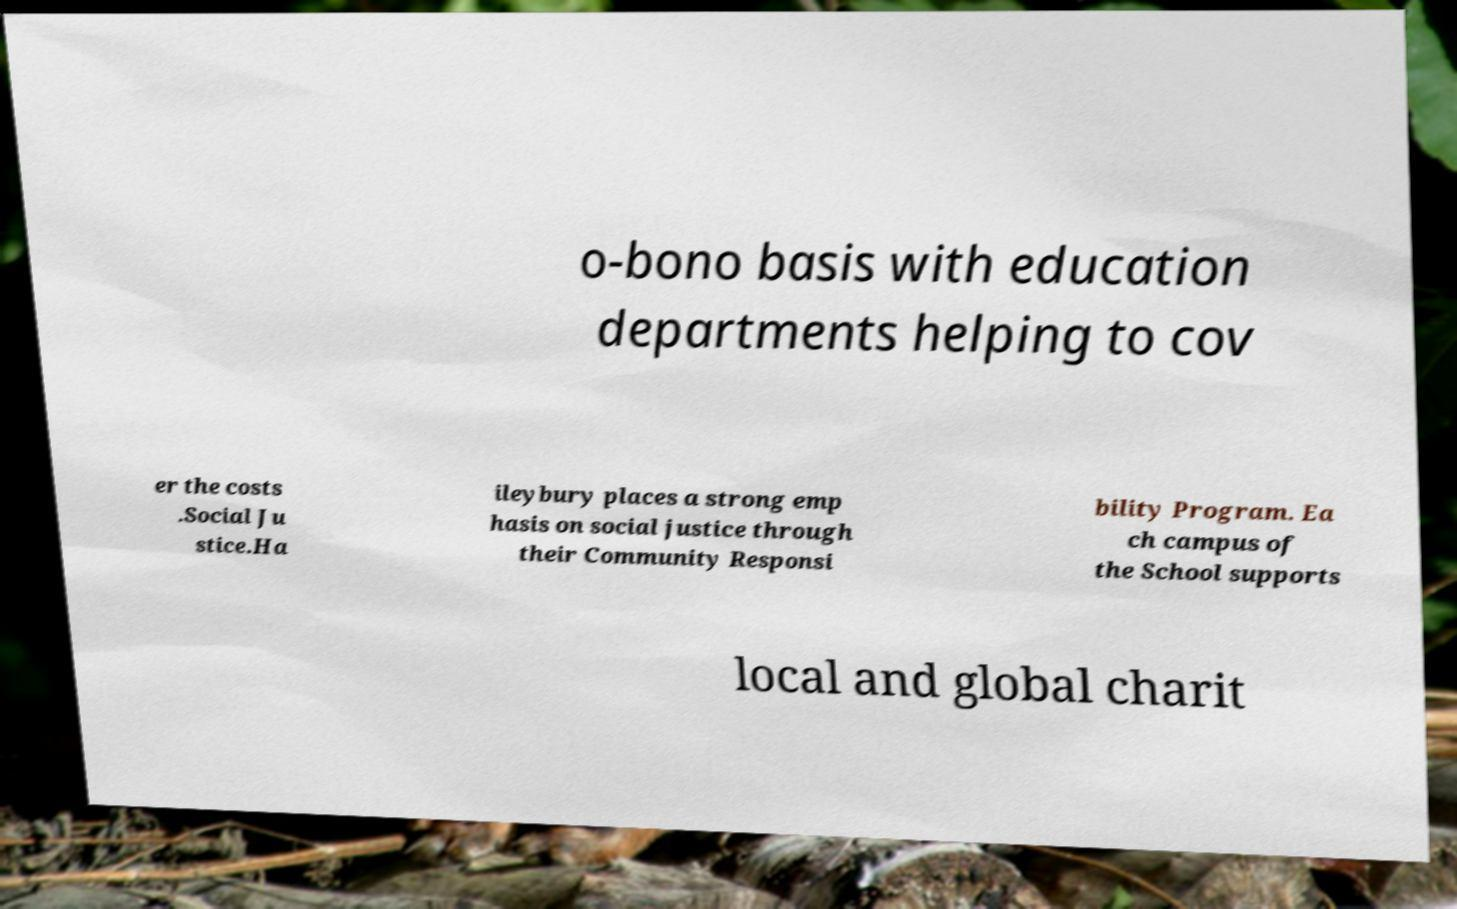Could you extract and type out the text from this image? o-bono basis with education departments helping to cov er the costs .Social Ju stice.Ha ileybury places a strong emp hasis on social justice through their Community Responsi bility Program. Ea ch campus of the School supports local and global charit 